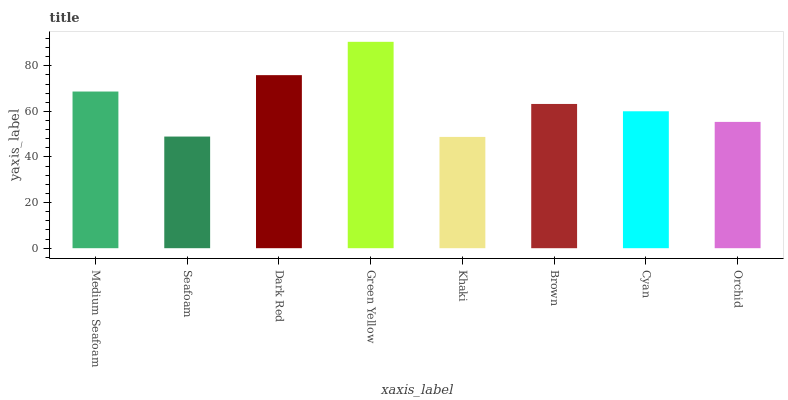Is Khaki the minimum?
Answer yes or no. Yes. Is Green Yellow the maximum?
Answer yes or no. Yes. Is Seafoam the minimum?
Answer yes or no. No. Is Seafoam the maximum?
Answer yes or no. No. Is Medium Seafoam greater than Seafoam?
Answer yes or no. Yes. Is Seafoam less than Medium Seafoam?
Answer yes or no. Yes. Is Seafoam greater than Medium Seafoam?
Answer yes or no. No. Is Medium Seafoam less than Seafoam?
Answer yes or no. No. Is Brown the high median?
Answer yes or no. Yes. Is Cyan the low median?
Answer yes or no. Yes. Is Green Yellow the high median?
Answer yes or no. No. Is Green Yellow the low median?
Answer yes or no. No. 